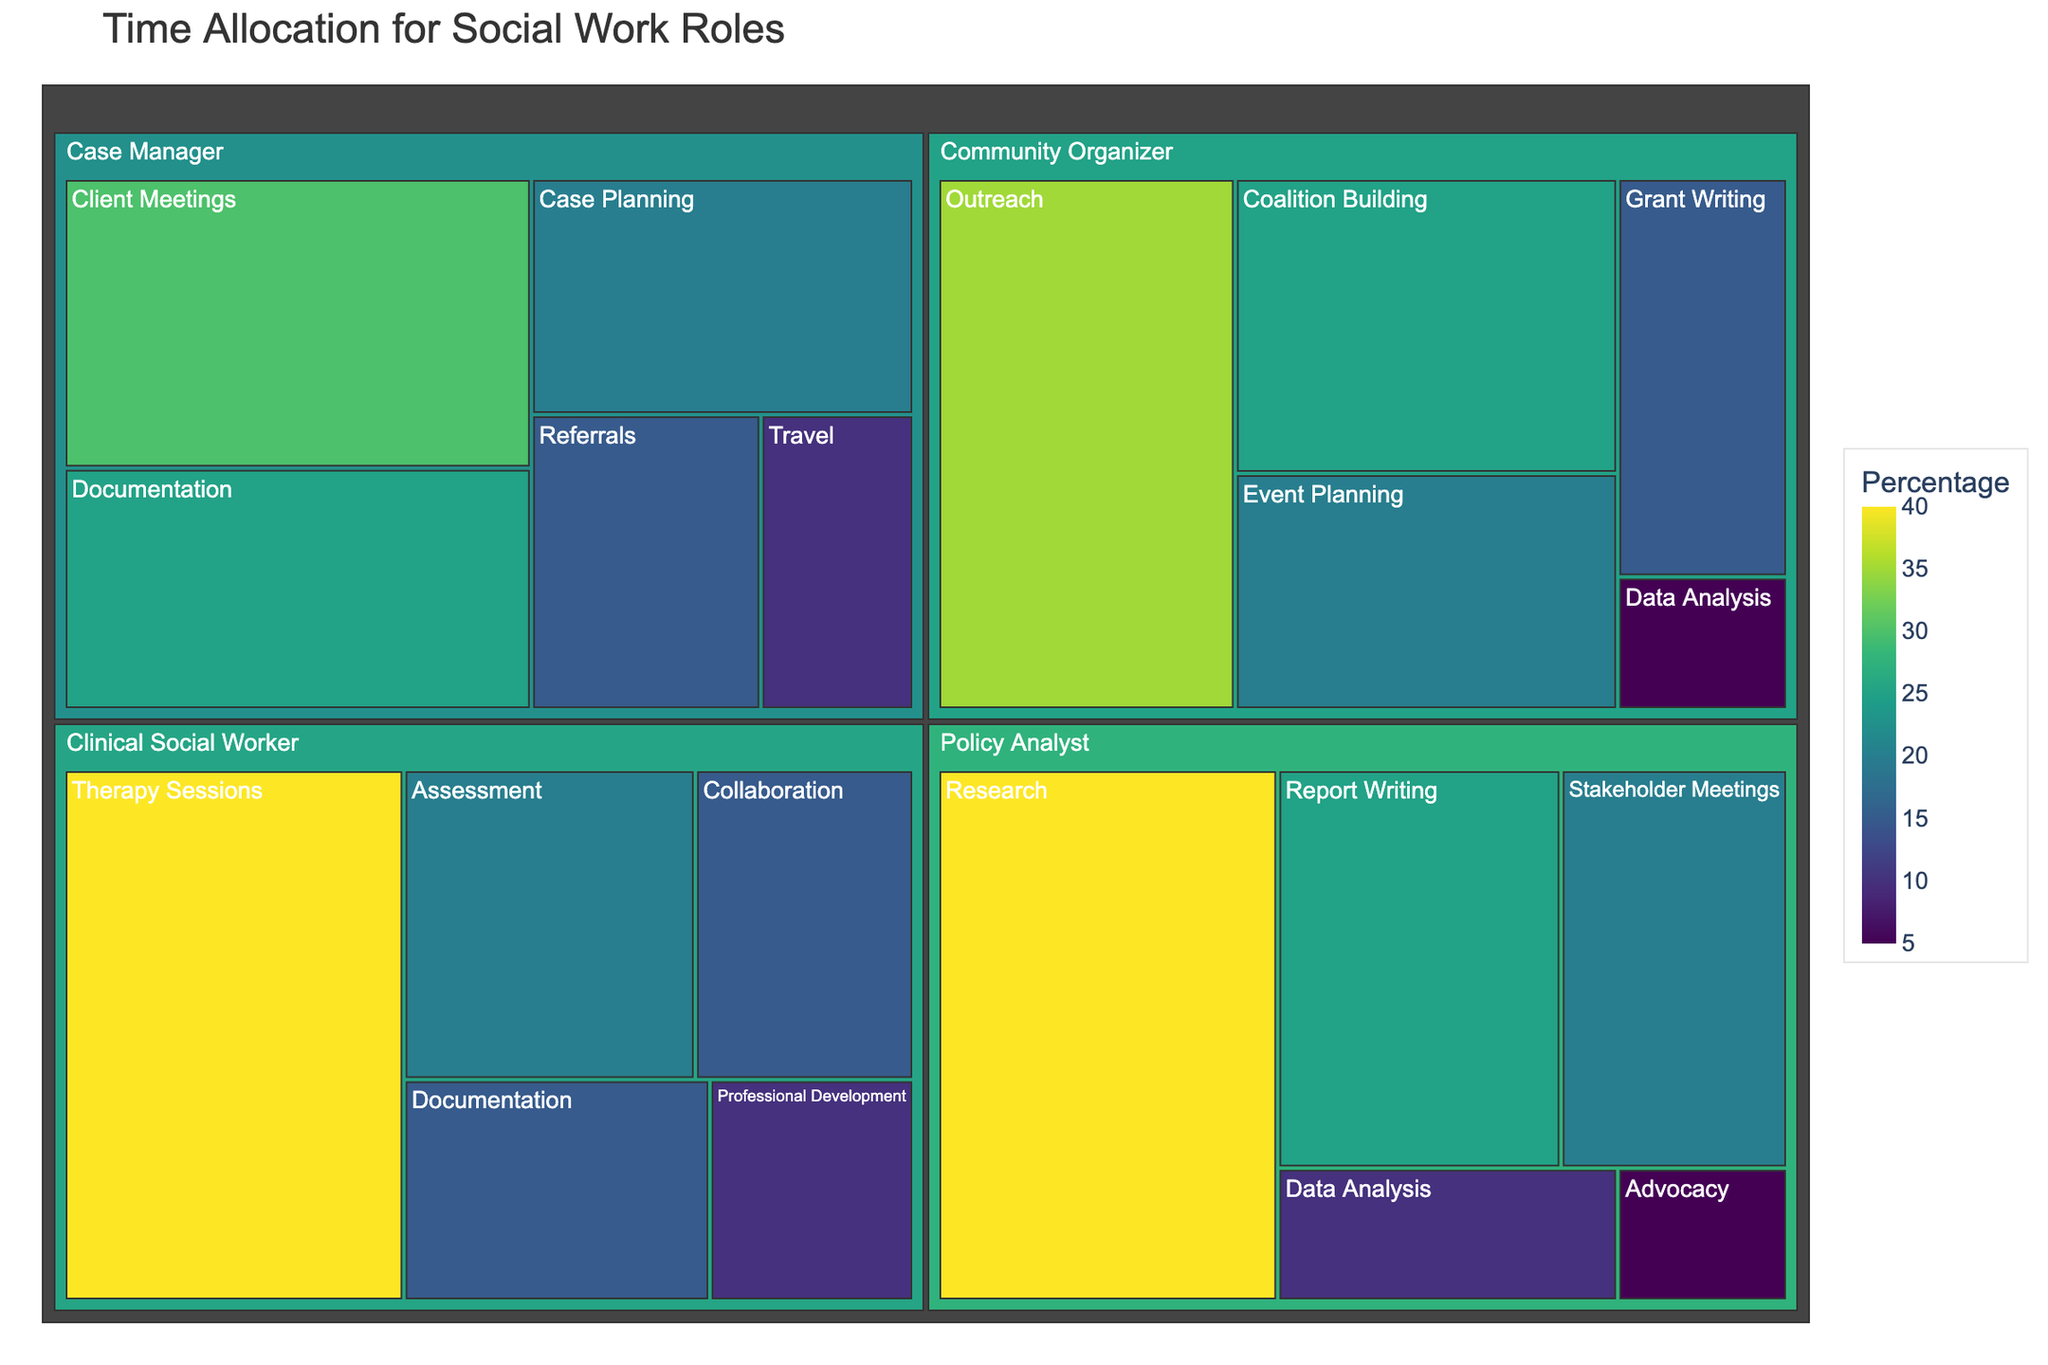What is the title of the treemap? The title of the treemap is the main heading that appears at the top of the visual. It provides an overview of what the visual represents.
Answer: Time Allocation for Social Work Roles Which activity has the highest percentage for the role of a Clinical Social Worker? Look for the largest section under the "Clinical Social Worker" category in the treemap to identify which activity has the highest percentage.
Answer: Therapy Sessions What percentage of time does a Policy Analyst spend on Research? Locate the "Policy Analyst" section in the treemap, and then find the "Research" sub-section to see its percentage value.
Answer: 40% How much more time do Community Organizers spend on Outreach compared to Data Analysis? Find the percentage values for both "Outreach" and "Data Analysis" under the "Community Organizer" category, then calculate the difference.
Answer: 30% Which role dedicates the overall highest percentage to a single activity? Look at the entire treemap to identify which individual activity has the highest percentage and then see which role it belongs to.
Answer: Clinical Social Worker (Therapy Sessions) What is the combined percentage of time spent on Documentation by Case Managers and Clinical Social Workers? Locate the "Documentation" sections under "Case Managers" and "Clinical Social Workers," then sum their percentages together.
Answer: 40% Do Policy Analysts and Community Organizers dedicate the same percentage of time to Data Analysis? Locate the "Data Analysis" sections under both "Policy Analysts" and "Community Organizers," and check if their percentages are equal.
Answer: Yes Which activity under Case Manager has the lowest percentage? Find the smallest section under the "Case Manager" category in the treemap to identify which activity has the lowest percentage.
Answer: Travel How does the percentage of time spent on Client Meetings by Case Managers compare to Assessment by Clinical Social Workers? Compare the percentage values of "Client Meetings" under Case Managers and "Assessment" under Clinical Social Workers to see which is higher.
Answer: Client Meetings (Case Managers) What is the total percentage of time spent on various activities by social workers in non-clinical roles (Case Manager, Community Organizer, Policy Analyst)? Sum the percentages of all activities listed under "Case Manager," "Community Organizer," and "Policy Analyst."
Answer: 100% 